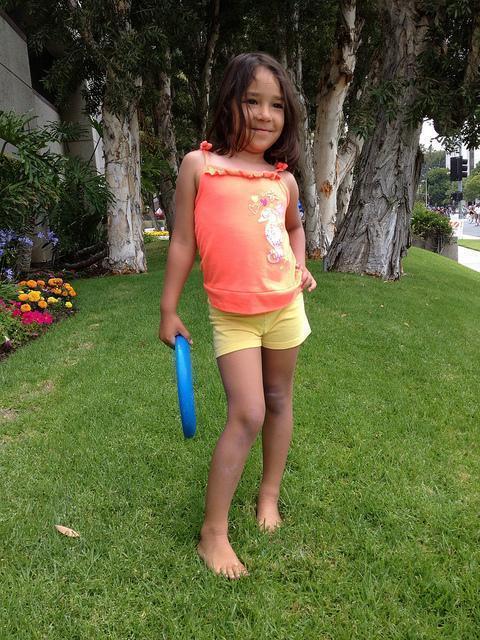The girl is positioning her body in the way a model does by doing what?
Select the accurate response from the four choices given to answer the question.
Options: Walking, posing, crying, twirling. Posing. 